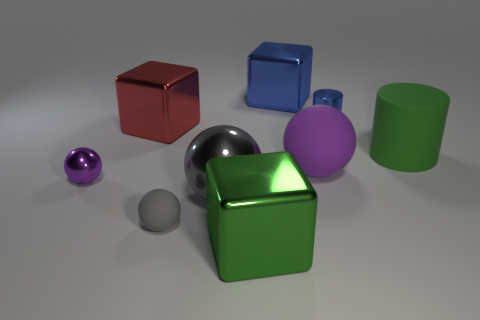Add 1 gray things. How many objects exist? 10 Subtract all balls. How many objects are left? 5 Add 5 matte cylinders. How many matte cylinders exist? 6 Subtract 0 red balls. How many objects are left? 9 Subtract all big purple matte objects. Subtract all tiny objects. How many objects are left? 5 Add 8 tiny gray matte spheres. How many tiny gray matte spheres are left? 9 